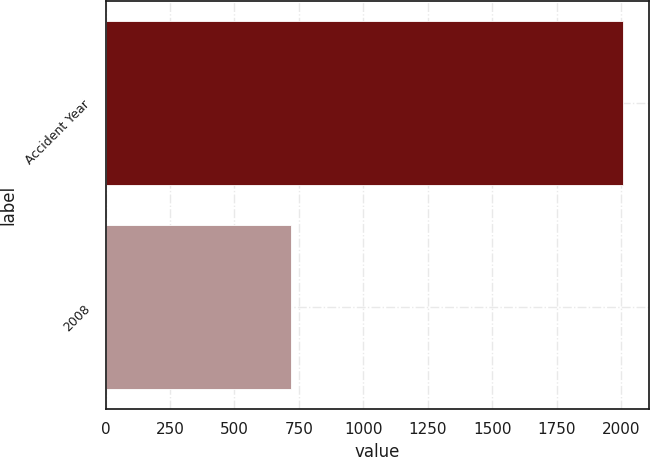Convert chart. <chart><loc_0><loc_0><loc_500><loc_500><bar_chart><fcel>Accident Year<fcel>2008<nl><fcel>2009<fcel>721<nl></chart> 